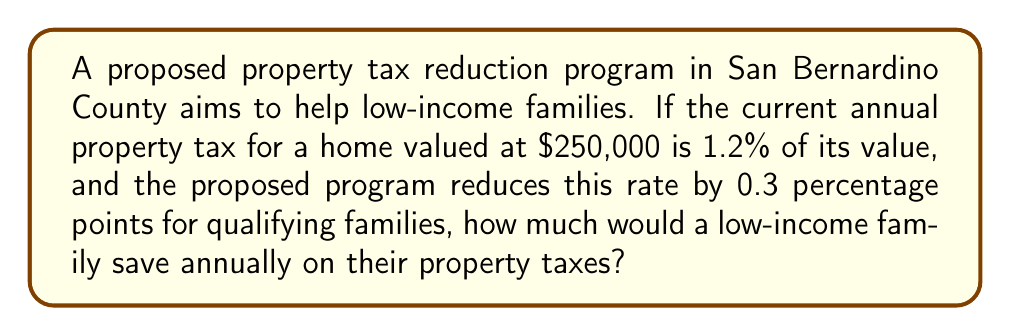Solve this math problem. Let's approach this problem step-by-step:

1) First, calculate the current property tax:
   Current tax rate = 1.2% = 0.012
   Home value = $250,000
   Current annual tax = $250,000 × 0.012 = $3,000

2) Now, calculate the new property tax rate:
   New tax rate = Current rate - Reduction
   New tax rate = 1.2% - 0.3% = 0.9% = 0.009

3) Calculate the new annual property tax:
   New annual tax = $250,000 × 0.009 = $2,250

4) Finally, calculate the annual savings:
   Annual savings = Current tax - New tax
   Annual savings = $3,000 - $2,250 = $750

Therefore, a low-income family would save $750 annually on their property taxes under this proposed program.
Answer: $750 